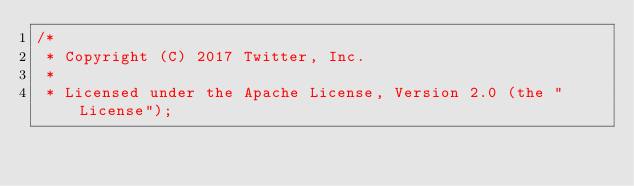Convert code to text. <code><loc_0><loc_0><loc_500><loc_500><_C_>/*
 * Copyright (C) 2017 Twitter, Inc.
 *
 * Licensed under the Apache License, Version 2.0 (the "License");</code> 